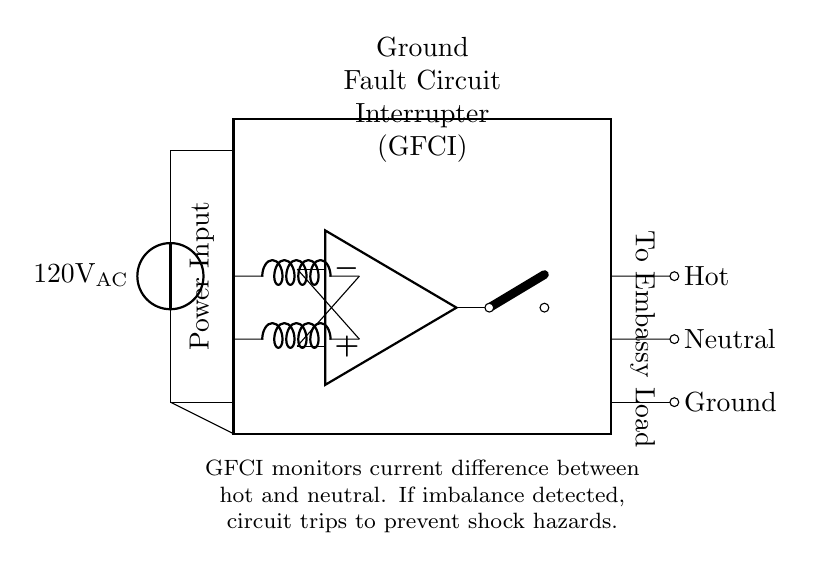What type of device is represented in the diagram? The diagram prominently features a Ground Fault Circuit Interrupter (GFCI), which is a protective component designed to prevent electrical shocks by monitoring current.
Answer: Ground Fault Circuit Interrupter What is the AC voltage supplied to the GFCI? The circuit diagram indicates the voltage source is labeled as 120 volts AC, which is the standard voltage supplied for most residential and light commercial applications.
Answer: 120 volts AC What does the GFCI monitor to ensure safety? The GFCI monitors the current difference between the hot and neutral wires in the circuit, which allows it to detect any imbalance that could indicate a potential ground fault.
Answer: Current difference What is the purpose of the trip circuit in the GFCI? The trip circuit is connected to the differential amplifier, and it serves the purpose of interrupting the circuit when a fault is detected, thereby preventing electrical shock hazards.
Answer: Interrupt the circuit How does the GFCI respond to an imbalance in current? When the GFCI detects an imbalance in current through the differential amplifier, it actuates the trip circuit to open the switch, immediately cutting off power to the load connected downstream, ensuring safety.
Answer: Opens the switch What component is used for sensing current in this diagram? The GFCI includes inductors as sensing coils, which detect changes in current between the hot and neutral conductors and are integral to its operation.
Answer: Inductors 